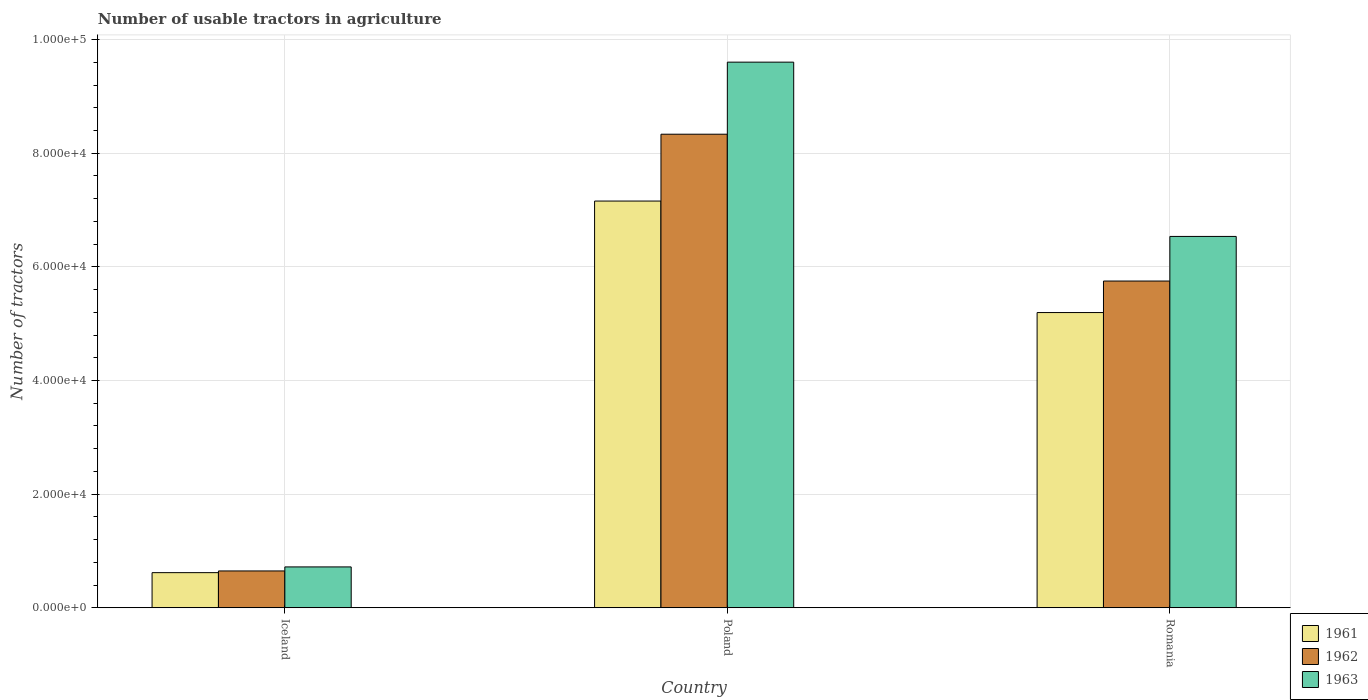How many different coloured bars are there?
Offer a very short reply. 3. Are the number of bars per tick equal to the number of legend labels?
Provide a succinct answer. Yes. Are the number of bars on each tick of the X-axis equal?
Ensure brevity in your answer.  Yes. How many bars are there on the 3rd tick from the left?
Your answer should be compact. 3. What is the label of the 1st group of bars from the left?
Keep it short and to the point. Iceland. What is the number of usable tractors in agriculture in 1961 in Iceland?
Give a very brief answer. 6177. Across all countries, what is the maximum number of usable tractors in agriculture in 1961?
Provide a succinct answer. 7.16e+04. Across all countries, what is the minimum number of usable tractors in agriculture in 1961?
Your response must be concise. 6177. In which country was the number of usable tractors in agriculture in 1961 maximum?
Your answer should be very brief. Poland. What is the total number of usable tractors in agriculture in 1963 in the graph?
Your response must be concise. 1.69e+05. What is the difference between the number of usable tractors in agriculture in 1961 in Iceland and that in Poland?
Keep it short and to the point. -6.54e+04. What is the difference between the number of usable tractors in agriculture in 1963 in Poland and the number of usable tractors in agriculture in 1962 in Romania?
Offer a very short reply. 3.85e+04. What is the average number of usable tractors in agriculture in 1961 per country?
Make the answer very short. 4.32e+04. What is the difference between the number of usable tractors in agriculture of/in 1961 and number of usable tractors in agriculture of/in 1962 in Poland?
Provide a succinct answer. -1.18e+04. In how many countries, is the number of usable tractors in agriculture in 1961 greater than 68000?
Your answer should be very brief. 1. What is the ratio of the number of usable tractors in agriculture in 1963 in Poland to that in Romania?
Provide a succinct answer. 1.47. What is the difference between the highest and the second highest number of usable tractors in agriculture in 1962?
Your answer should be very brief. -2.58e+04. What is the difference between the highest and the lowest number of usable tractors in agriculture in 1961?
Ensure brevity in your answer.  6.54e+04. What does the 2nd bar from the left in Poland represents?
Provide a succinct answer. 1962. Is it the case that in every country, the sum of the number of usable tractors in agriculture in 1963 and number of usable tractors in agriculture in 1962 is greater than the number of usable tractors in agriculture in 1961?
Ensure brevity in your answer.  Yes. How many bars are there?
Your answer should be very brief. 9. How many countries are there in the graph?
Keep it short and to the point. 3. What is the difference between two consecutive major ticks on the Y-axis?
Give a very brief answer. 2.00e+04. How many legend labels are there?
Keep it short and to the point. 3. How are the legend labels stacked?
Offer a very short reply. Vertical. What is the title of the graph?
Provide a succinct answer. Number of usable tractors in agriculture. Does "1970" appear as one of the legend labels in the graph?
Provide a short and direct response. No. What is the label or title of the Y-axis?
Provide a succinct answer. Number of tractors. What is the Number of tractors in 1961 in Iceland?
Your answer should be very brief. 6177. What is the Number of tractors of 1962 in Iceland?
Provide a short and direct response. 6479. What is the Number of tractors in 1963 in Iceland?
Give a very brief answer. 7187. What is the Number of tractors of 1961 in Poland?
Your answer should be very brief. 7.16e+04. What is the Number of tractors in 1962 in Poland?
Offer a very short reply. 8.33e+04. What is the Number of tractors of 1963 in Poland?
Your answer should be very brief. 9.60e+04. What is the Number of tractors of 1961 in Romania?
Your answer should be compact. 5.20e+04. What is the Number of tractors of 1962 in Romania?
Provide a succinct answer. 5.75e+04. What is the Number of tractors in 1963 in Romania?
Give a very brief answer. 6.54e+04. Across all countries, what is the maximum Number of tractors in 1961?
Make the answer very short. 7.16e+04. Across all countries, what is the maximum Number of tractors of 1962?
Keep it short and to the point. 8.33e+04. Across all countries, what is the maximum Number of tractors of 1963?
Your answer should be very brief. 9.60e+04. Across all countries, what is the minimum Number of tractors of 1961?
Ensure brevity in your answer.  6177. Across all countries, what is the minimum Number of tractors of 1962?
Provide a succinct answer. 6479. Across all countries, what is the minimum Number of tractors of 1963?
Make the answer very short. 7187. What is the total Number of tractors of 1961 in the graph?
Provide a short and direct response. 1.30e+05. What is the total Number of tractors in 1962 in the graph?
Keep it short and to the point. 1.47e+05. What is the total Number of tractors in 1963 in the graph?
Offer a very short reply. 1.69e+05. What is the difference between the Number of tractors of 1961 in Iceland and that in Poland?
Offer a very short reply. -6.54e+04. What is the difference between the Number of tractors of 1962 in Iceland and that in Poland?
Give a very brief answer. -7.69e+04. What is the difference between the Number of tractors of 1963 in Iceland and that in Poland?
Your answer should be compact. -8.88e+04. What is the difference between the Number of tractors in 1961 in Iceland and that in Romania?
Ensure brevity in your answer.  -4.58e+04. What is the difference between the Number of tractors of 1962 in Iceland and that in Romania?
Provide a succinct answer. -5.10e+04. What is the difference between the Number of tractors in 1963 in Iceland and that in Romania?
Give a very brief answer. -5.82e+04. What is the difference between the Number of tractors in 1961 in Poland and that in Romania?
Offer a very short reply. 1.96e+04. What is the difference between the Number of tractors in 1962 in Poland and that in Romania?
Give a very brief answer. 2.58e+04. What is the difference between the Number of tractors in 1963 in Poland and that in Romania?
Offer a very short reply. 3.07e+04. What is the difference between the Number of tractors of 1961 in Iceland and the Number of tractors of 1962 in Poland?
Your response must be concise. -7.72e+04. What is the difference between the Number of tractors of 1961 in Iceland and the Number of tractors of 1963 in Poland?
Your response must be concise. -8.98e+04. What is the difference between the Number of tractors of 1962 in Iceland and the Number of tractors of 1963 in Poland?
Give a very brief answer. -8.95e+04. What is the difference between the Number of tractors in 1961 in Iceland and the Number of tractors in 1962 in Romania?
Offer a very short reply. -5.13e+04. What is the difference between the Number of tractors in 1961 in Iceland and the Number of tractors in 1963 in Romania?
Give a very brief answer. -5.92e+04. What is the difference between the Number of tractors of 1962 in Iceland and the Number of tractors of 1963 in Romania?
Your answer should be compact. -5.89e+04. What is the difference between the Number of tractors in 1961 in Poland and the Number of tractors in 1962 in Romania?
Ensure brevity in your answer.  1.41e+04. What is the difference between the Number of tractors of 1961 in Poland and the Number of tractors of 1963 in Romania?
Your answer should be very brief. 6226. What is the difference between the Number of tractors of 1962 in Poland and the Number of tractors of 1963 in Romania?
Your answer should be compact. 1.80e+04. What is the average Number of tractors in 1961 per country?
Keep it short and to the point. 4.32e+04. What is the average Number of tractors in 1962 per country?
Keep it short and to the point. 4.91e+04. What is the average Number of tractors in 1963 per country?
Offer a terse response. 5.62e+04. What is the difference between the Number of tractors in 1961 and Number of tractors in 1962 in Iceland?
Your response must be concise. -302. What is the difference between the Number of tractors of 1961 and Number of tractors of 1963 in Iceland?
Offer a very short reply. -1010. What is the difference between the Number of tractors in 1962 and Number of tractors in 1963 in Iceland?
Make the answer very short. -708. What is the difference between the Number of tractors of 1961 and Number of tractors of 1962 in Poland?
Your answer should be compact. -1.18e+04. What is the difference between the Number of tractors in 1961 and Number of tractors in 1963 in Poland?
Your response must be concise. -2.44e+04. What is the difference between the Number of tractors in 1962 and Number of tractors in 1963 in Poland?
Make the answer very short. -1.27e+04. What is the difference between the Number of tractors of 1961 and Number of tractors of 1962 in Romania?
Keep it short and to the point. -5548. What is the difference between the Number of tractors of 1961 and Number of tractors of 1963 in Romania?
Your answer should be compact. -1.34e+04. What is the difference between the Number of tractors in 1962 and Number of tractors in 1963 in Romania?
Offer a terse response. -7851. What is the ratio of the Number of tractors of 1961 in Iceland to that in Poland?
Make the answer very short. 0.09. What is the ratio of the Number of tractors in 1962 in Iceland to that in Poland?
Ensure brevity in your answer.  0.08. What is the ratio of the Number of tractors of 1963 in Iceland to that in Poland?
Give a very brief answer. 0.07. What is the ratio of the Number of tractors in 1961 in Iceland to that in Romania?
Provide a short and direct response. 0.12. What is the ratio of the Number of tractors in 1962 in Iceland to that in Romania?
Provide a short and direct response. 0.11. What is the ratio of the Number of tractors in 1963 in Iceland to that in Romania?
Your response must be concise. 0.11. What is the ratio of the Number of tractors in 1961 in Poland to that in Romania?
Your answer should be very brief. 1.38. What is the ratio of the Number of tractors in 1962 in Poland to that in Romania?
Provide a succinct answer. 1.45. What is the ratio of the Number of tractors of 1963 in Poland to that in Romania?
Keep it short and to the point. 1.47. What is the difference between the highest and the second highest Number of tractors of 1961?
Provide a succinct answer. 1.96e+04. What is the difference between the highest and the second highest Number of tractors in 1962?
Ensure brevity in your answer.  2.58e+04. What is the difference between the highest and the second highest Number of tractors in 1963?
Offer a terse response. 3.07e+04. What is the difference between the highest and the lowest Number of tractors in 1961?
Your answer should be very brief. 6.54e+04. What is the difference between the highest and the lowest Number of tractors in 1962?
Your response must be concise. 7.69e+04. What is the difference between the highest and the lowest Number of tractors of 1963?
Your answer should be compact. 8.88e+04. 